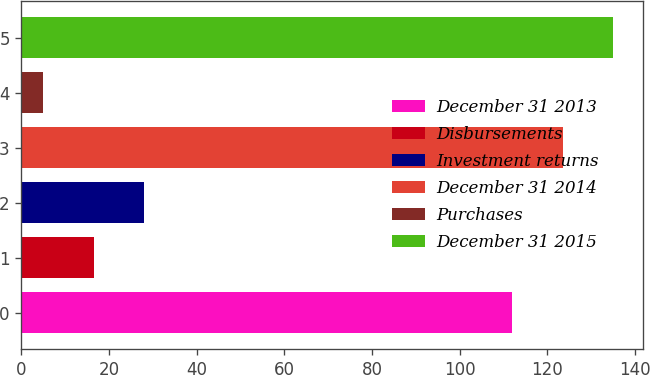Convert chart. <chart><loc_0><loc_0><loc_500><loc_500><bar_chart><fcel>December 31 2013<fcel>Disbursements<fcel>Investment returns<fcel>December 31 2014<fcel>Purchases<fcel>December 31 2015<nl><fcel>112<fcel>16.5<fcel>28<fcel>123.5<fcel>5<fcel>135<nl></chart> 